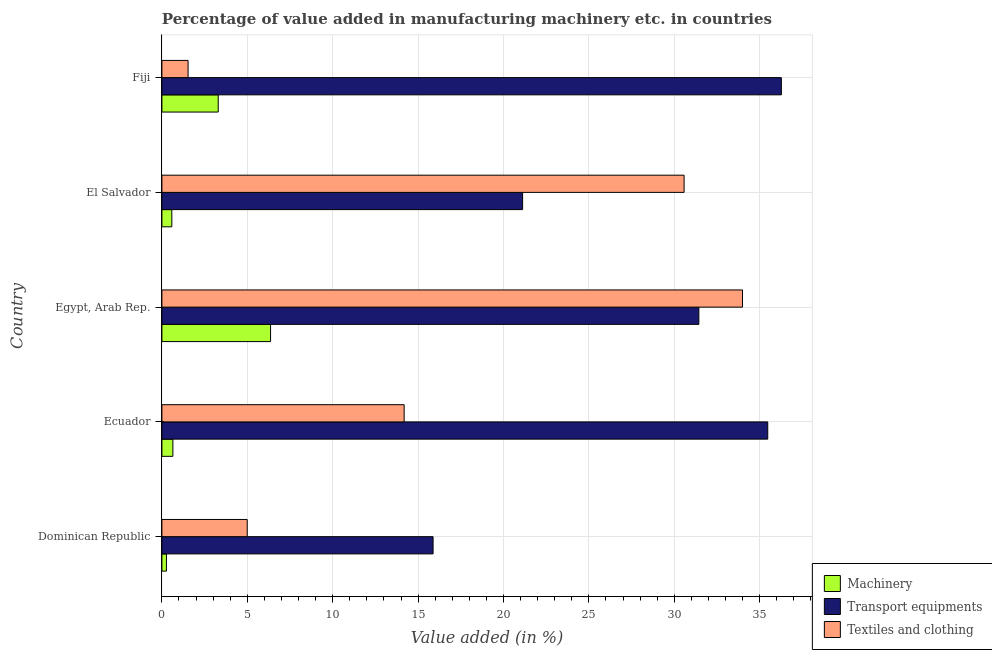How many different coloured bars are there?
Provide a short and direct response. 3. How many groups of bars are there?
Ensure brevity in your answer.  5. How many bars are there on the 4th tick from the top?
Your answer should be very brief. 3. How many bars are there on the 4th tick from the bottom?
Offer a very short reply. 3. What is the label of the 1st group of bars from the top?
Provide a succinct answer. Fiji. What is the value added in manufacturing machinery in El Salvador?
Provide a succinct answer. 0.58. Across all countries, what is the maximum value added in manufacturing transport equipments?
Keep it short and to the point. 36.27. Across all countries, what is the minimum value added in manufacturing machinery?
Ensure brevity in your answer.  0.27. In which country was the value added in manufacturing textile and clothing maximum?
Your answer should be very brief. Egypt, Arab Rep. In which country was the value added in manufacturing textile and clothing minimum?
Give a very brief answer. Fiji. What is the total value added in manufacturing machinery in the graph?
Keep it short and to the point. 11.15. What is the difference between the value added in manufacturing transport equipments in Dominican Republic and that in Fiji?
Your answer should be compact. -20.39. What is the difference between the value added in manufacturing machinery in Dominican Republic and the value added in manufacturing textile and clothing in Egypt, Arab Rep.?
Your answer should be compact. -33.73. What is the average value added in manufacturing machinery per country?
Your answer should be compact. 2.23. What is the difference between the value added in manufacturing textile and clothing and value added in manufacturing transport equipments in Dominican Republic?
Offer a terse response. -10.88. In how many countries, is the value added in manufacturing machinery greater than 4 %?
Your answer should be very brief. 1. What is the ratio of the value added in manufacturing textile and clothing in Egypt, Arab Rep. to that in El Salvador?
Ensure brevity in your answer.  1.11. Is the value added in manufacturing machinery in Ecuador less than that in Egypt, Arab Rep.?
Your answer should be very brief. Yes. Is the difference between the value added in manufacturing textile and clothing in Dominican Republic and El Salvador greater than the difference between the value added in manufacturing machinery in Dominican Republic and El Salvador?
Provide a succinct answer. No. What is the difference between the highest and the second highest value added in manufacturing textile and clothing?
Your answer should be compact. 3.42. What is the difference between the highest and the lowest value added in manufacturing textile and clothing?
Ensure brevity in your answer.  32.46. What does the 1st bar from the top in Dominican Republic represents?
Offer a terse response. Textiles and clothing. What does the 2nd bar from the bottom in Ecuador represents?
Make the answer very short. Transport equipments. Is it the case that in every country, the sum of the value added in manufacturing machinery and value added in manufacturing transport equipments is greater than the value added in manufacturing textile and clothing?
Provide a short and direct response. No. What is the difference between two consecutive major ticks on the X-axis?
Ensure brevity in your answer.  5. Does the graph contain grids?
Provide a succinct answer. Yes. What is the title of the graph?
Ensure brevity in your answer.  Percentage of value added in manufacturing machinery etc. in countries. Does "Tertiary" appear as one of the legend labels in the graph?
Ensure brevity in your answer.  No. What is the label or title of the X-axis?
Ensure brevity in your answer.  Value added (in %). What is the label or title of the Y-axis?
Provide a short and direct response. Country. What is the Value added (in %) of Machinery in Dominican Republic?
Offer a very short reply. 0.27. What is the Value added (in %) in Transport equipments in Dominican Republic?
Offer a very short reply. 15.88. What is the Value added (in %) in Textiles and clothing in Dominican Republic?
Offer a terse response. 5. What is the Value added (in %) of Machinery in Ecuador?
Keep it short and to the point. 0.64. What is the Value added (in %) in Transport equipments in Ecuador?
Provide a succinct answer. 35.47. What is the Value added (in %) in Textiles and clothing in Ecuador?
Provide a short and direct response. 14.18. What is the Value added (in %) of Machinery in Egypt, Arab Rep.?
Ensure brevity in your answer.  6.36. What is the Value added (in %) of Transport equipments in Egypt, Arab Rep.?
Keep it short and to the point. 31.44. What is the Value added (in %) in Textiles and clothing in Egypt, Arab Rep.?
Make the answer very short. 33.99. What is the Value added (in %) in Machinery in El Salvador?
Ensure brevity in your answer.  0.58. What is the Value added (in %) of Transport equipments in El Salvador?
Ensure brevity in your answer.  21.12. What is the Value added (in %) of Textiles and clothing in El Salvador?
Give a very brief answer. 30.57. What is the Value added (in %) of Machinery in Fiji?
Your response must be concise. 3.3. What is the Value added (in %) of Transport equipments in Fiji?
Provide a short and direct response. 36.27. What is the Value added (in %) in Textiles and clothing in Fiji?
Your answer should be very brief. 1.53. Across all countries, what is the maximum Value added (in %) of Machinery?
Your response must be concise. 6.36. Across all countries, what is the maximum Value added (in %) in Transport equipments?
Offer a terse response. 36.27. Across all countries, what is the maximum Value added (in %) in Textiles and clothing?
Keep it short and to the point. 33.99. Across all countries, what is the minimum Value added (in %) of Machinery?
Offer a terse response. 0.27. Across all countries, what is the minimum Value added (in %) of Transport equipments?
Offer a terse response. 15.88. Across all countries, what is the minimum Value added (in %) in Textiles and clothing?
Your response must be concise. 1.53. What is the total Value added (in %) in Machinery in the graph?
Provide a succinct answer. 11.15. What is the total Value added (in %) in Transport equipments in the graph?
Give a very brief answer. 140.18. What is the total Value added (in %) of Textiles and clothing in the graph?
Your answer should be compact. 85.28. What is the difference between the Value added (in %) in Machinery in Dominican Republic and that in Ecuador?
Your answer should be very brief. -0.38. What is the difference between the Value added (in %) in Transport equipments in Dominican Republic and that in Ecuador?
Ensure brevity in your answer.  -19.59. What is the difference between the Value added (in %) in Textiles and clothing in Dominican Republic and that in Ecuador?
Give a very brief answer. -9.19. What is the difference between the Value added (in %) in Machinery in Dominican Republic and that in Egypt, Arab Rep.?
Offer a very short reply. -6.1. What is the difference between the Value added (in %) of Transport equipments in Dominican Republic and that in Egypt, Arab Rep.?
Your answer should be compact. -15.56. What is the difference between the Value added (in %) in Textiles and clothing in Dominican Republic and that in Egypt, Arab Rep.?
Provide a succinct answer. -29. What is the difference between the Value added (in %) in Machinery in Dominican Republic and that in El Salvador?
Your answer should be compact. -0.32. What is the difference between the Value added (in %) in Transport equipments in Dominican Republic and that in El Salvador?
Make the answer very short. -5.24. What is the difference between the Value added (in %) in Textiles and clothing in Dominican Republic and that in El Salvador?
Ensure brevity in your answer.  -25.58. What is the difference between the Value added (in %) of Machinery in Dominican Republic and that in Fiji?
Your answer should be compact. -3.03. What is the difference between the Value added (in %) in Transport equipments in Dominican Republic and that in Fiji?
Keep it short and to the point. -20.39. What is the difference between the Value added (in %) of Textiles and clothing in Dominican Republic and that in Fiji?
Your answer should be compact. 3.46. What is the difference between the Value added (in %) in Machinery in Ecuador and that in Egypt, Arab Rep.?
Offer a very short reply. -5.72. What is the difference between the Value added (in %) in Transport equipments in Ecuador and that in Egypt, Arab Rep.?
Give a very brief answer. 4.03. What is the difference between the Value added (in %) of Textiles and clothing in Ecuador and that in Egypt, Arab Rep.?
Provide a short and direct response. -19.81. What is the difference between the Value added (in %) in Machinery in Ecuador and that in El Salvador?
Offer a very short reply. 0.06. What is the difference between the Value added (in %) of Transport equipments in Ecuador and that in El Salvador?
Offer a terse response. 14.35. What is the difference between the Value added (in %) in Textiles and clothing in Ecuador and that in El Salvador?
Provide a short and direct response. -16.39. What is the difference between the Value added (in %) of Machinery in Ecuador and that in Fiji?
Keep it short and to the point. -2.65. What is the difference between the Value added (in %) of Transport equipments in Ecuador and that in Fiji?
Give a very brief answer. -0.8. What is the difference between the Value added (in %) in Textiles and clothing in Ecuador and that in Fiji?
Ensure brevity in your answer.  12.65. What is the difference between the Value added (in %) in Machinery in Egypt, Arab Rep. and that in El Salvador?
Make the answer very short. 5.78. What is the difference between the Value added (in %) in Transport equipments in Egypt, Arab Rep. and that in El Salvador?
Give a very brief answer. 10.32. What is the difference between the Value added (in %) of Textiles and clothing in Egypt, Arab Rep. and that in El Salvador?
Ensure brevity in your answer.  3.42. What is the difference between the Value added (in %) in Machinery in Egypt, Arab Rep. and that in Fiji?
Give a very brief answer. 3.06. What is the difference between the Value added (in %) of Transport equipments in Egypt, Arab Rep. and that in Fiji?
Your answer should be compact. -4.83. What is the difference between the Value added (in %) in Textiles and clothing in Egypt, Arab Rep. and that in Fiji?
Offer a very short reply. 32.46. What is the difference between the Value added (in %) in Machinery in El Salvador and that in Fiji?
Provide a short and direct response. -2.72. What is the difference between the Value added (in %) in Transport equipments in El Salvador and that in Fiji?
Provide a short and direct response. -15.15. What is the difference between the Value added (in %) of Textiles and clothing in El Salvador and that in Fiji?
Your response must be concise. 29.04. What is the difference between the Value added (in %) in Machinery in Dominican Republic and the Value added (in %) in Transport equipments in Ecuador?
Your answer should be compact. -35.21. What is the difference between the Value added (in %) of Machinery in Dominican Republic and the Value added (in %) of Textiles and clothing in Ecuador?
Your response must be concise. -13.92. What is the difference between the Value added (in %) in Transport equipments in Dominican Republic and the Value added (in %) in Textiles and clothing in Ecuador?
Ensure brevity in your answer.  1.69. What is the difference between the Value added (in %) of Machinery in Dominican Republic and the Value added (in %) of Transport equipments in Egypt, Arab Rep.?
Provide a succinct answer. -31.17. What is the difference between the Value added (in %) in Machinery in Dominican Republic and the Value added (in %) in Textiles and clothing in Egypt, Arab Rep.?
Offer a terse response. -33.73. What is the difference between the Value added (in %) in Transport equipments in Dominican Republic and the Value added (in %) in Textiles and clothing in Egypt, Arab Rep.?
Give a very brief answer. -18.12. What is the difference between the Value added (in %) of Machinery in Dominican Republic and the Value added (in %) of Transport equipments in El Salvador?
Your answer should be very brief. -20.85. What is the difference between the Value added (in %) in Machinery in Dominican Republic and the Value added (in %) in Textiles and clothing in El Salvador?
Make the answer very short. -30.31. What is the difference between the Value added (in %) in Transport equipments in Dominican Republic and the Value added (in %) in Textiles and clothing in El Salvador?
Keep it short and to the point. -14.7. What is the difference between the Value added (in %) of Machinery in Dominican Republic and the Value added (in %) of Transport equipments in Fiji?
Offer a very short reply. -36. What is the difference between the Value added (in %) of Machinery in Dominican Republic and the Value added (in %) of Textiles and clothing in Fiji?
Provide a short and direct response. -1.27. What is the difference between the Value added (in %) of Transport equipments in Dominican Republic and the Value added (in %) of Textiles and clothing in Fiji?
Make the answer very short. 14.34. What is the difference between the Value added (in %) of Machinery in Ecuador and the Value added (in %) of Transport equipments in Egypt, Arab Rep.?
Your response must be concise. -30.79. What is the difference between the Value added (in %) of Machinery in Ecuador and the Value added (in %) of Textiles and clothing in Egypt, Arab Rep.?
Offer a very short reply. -33.35. What is the difference between the Value added (in %) in Transport equipments in Ecuador and the Value added (in %) in Textiles and clothing in Egypt, Arab Rep.?
Your response must be concise. 1.48. What is the difference between the Value added (in %) of Machinery in Ecuador and the Value added (in %) of Transport equipments in El Salvador?
Offer a very short reply. -20.48. What is the difference between the Value added (in %) in Machinery in Ecuador and the Value added (in %) in Textiles and clothing in El Salvador?
Offer a very short reply. -29.93. What is the difference between the Value added (in %) in Transport equipments in Ecuador and the Value added (in %) in Textiles and clothing in El Salvador?
Keep it short and to the point. 4.9. What is the difference between the Value added (in %) of Machinery in Ecuador and the Value added (in %) of Transport equipments in Fiji?
Provide a succinct answer. -35.63. What is the difference between the Value added (in %) in Machinery in Ecuador and the Value added (in %) in Textiles and clothing in Fiji?
Provide a succinct answer. -0.89. What is the difference between the Value added (in %) of Transport equipments in Ecuador and the Value added (in %) of Textiles and clothing in Fiji?
Provide a succinct answer. 33.94. What is the difference between the Value added (in %) of Machinery in Egypt, Arab Rep. and the Value added (in %) of Transport equipments in El Salvador?
Offer a very short reply. -14.76. What is the difference between the Value added (in %) in Machinery in Egypt, Arab Rep. and the Value added (in %) in Textiles and clothing in El Salvador?
Offer a very short reply. -24.21. What is the difference between the Value added (in %) in Transport equipments in Egypt, Arab Rep. and the Value added (in %) in Textiles and clothing in El Salvador?
Make the answer very short. 0.86. What is the difference between the Value added (in %) of Machinery in Egypt, Arab Rep. and the Value added (in %) of Transport equipments in Fiji?
Offer a terse response. -29.91. What is the difference between the Value added (in %) in Machinery in Egypt, Arab Rep. and the Value added (in %) in Textiles and clothing in Fiji?
Provide a succinct answer. 4.83. What is the difference between the Value added (in %) in Transport equipments in Egypt, Arab Rep. and the Value added (in %) in Textiles and clothing in Fiji?
Your answer should be compact. 29.9. What is the difference between the Value added (in %) in Machinery in El Salvador and the Value added (in %) in Transport equipments in Fiji?
Provide a short and direct response. -35.69. What is the difference between the Value added (in %) in Machinery in El Salvador and the Value added (in %) in Textiles and clothing in Fiji?
Give a very brief answer. -0.95. What is the difference between the Value added (in %) in Transport equipments in El Salvador and the Value added (in %) in Textiles and clothing in Fiji?
Keep it short and to the point. 19.59. What is the average Value added (in %) in Machinery per country?
Your answer should be compact. 2.23. What is the average Value added (in %) in Transport equipments per country?
Offer a very short reply. 28.04. What is the average Value added (in %) in Textiles and clothing per country?
Provide a short and direct response. 17.06. What is the difference between the Value added (in %) in Machinery and Value added (in %) in Transport equipments in Dominican Republic?
Offer a terse response. -15.61. What is the difference between the Value added (in %) in Machinery and Value added (in %) in Textiles and clothing in Dominican Republic?
Keep it short and to the point. -4.73. What is the difference between the Value added (in %) of Transport equipments and Value added (in %) of Textiles and clothing in Dominican Republic?
Your answer should be compact. 10.88. What is the difference between the Value added (in %) in Machinery and Value added (in %) in Transport equipments in Ecuador?
Offer a terse response. -34.83. What is the difference between the Value added (in %) of Machinery and Value added (in %) of Textiles and clothing in Ecuador?
Make the answer very short. -13.54. What is the difference between the Value added (in %) in Transport equipments and Value added (in %) in Textiles and clothing in Ecuador?
Your answer should be compact. 21.29. What is the difference between the Value added (in %) of Machinery and Value added (in %) of Transport equipments in Egypt, Arab Rep.?
Your response must be concise. -25.08. What is the difference between the Value added (in %) of Machinery and Value added (in %) of Textiles and clothing in Egypt, Arab Rep.?
Offer a terse response. -27.63. What is the difference between the Value added (in %) of Transport equipments and Value added (in %) of Textiles and clothing in Egypt, Arab Rep.?
Offer a terse response. -2.56. What is the difference between the Value added (in %) of Machinery and Value added (in %) of Transport equipments in El Salvador?
Keep it short and to the point. -20.54. What is the difference between the Value added (in %) in Machinery and Value added (in %) in Textiles and clothing in El Salvador?
Your response must be concise. -29.99. What is the difference between the Value added (in %) of Transport equipments and Value added (in %) of Textiles and clothing in El Salvador?
Give a very brief answer. -9.46. What is the difference between the Value added (in %) of Machinery and Value added (in %) of Transport equipments in Fiji?
Give a very brief answer. -32.97. What is the difference between the Value added (in %) in Machinery and Value added (in %) in Textiles and clothing in Fiji?
Offer a very short reply. 1.77. What is the difference between the Value added (in %) of Transport equipments and Value added (in %) of Textiles and clothing in Fiji?
Give a very brief answer. 34.74. What is the ratio of the Value added (in %) in Machinery in Dominican Republic to that in Ecuador?
Give a very brief answer. 0.41. What is the ratio of the Value added (in %) in Transport equipments in Dominican Republic to that in Ecuador?
Keep it short and to the point. 0.45. What is the ratio of the Value added (in %) of Textiles and clothing in Dominican Republic to that in Ecuador?
Offer a very short reply. 0.35. What is the ratio of the Value added (in %) of Machinery in Dominican Republic to that in Egypt, Arab Rep.?
Keep it short and to the point. 0.04. What is the ratio of the Value added (in %) of Transport equipments in Dominican Republic to that in Egypt, Arab Rep.?
Make the answer very short. 0.51. What is the ratio of the Value added (in %) of Textiles and clothing in Dominican Republic to that in Egypt, Arab Rep.?
Make the answer very short. 0.15. What is the ratio of the Value added (in %) of Machinery in Dominican Republic to that in El Salvador?
Keep it short and to the point. 0.46. What is the ratio of the Value added (in %) of Transport equipments in Dominican Republic to that in El Salvador?
Make the answer very short. 0.75. What is the ratio of the Value added (in %) in Textiles and clothing in Dominican Republic to that in El Salvador?
Offer a very short reply. 0.16. What is the ratio of the Value added (in %) in Machinery in Dominican Republic to that in Fiji?
Provide a succinct answer. 0.08. What is the ratio of the Value added (in %) of Transport equipments in Dominican Republic to that in Fiji?
Give a very brief answer. 0.44. What is the ratio of the Value added (in %) of Textiles and clothing in Dominican Republic to that in Fiji?
Ensure brevity in your answer.  3.26. What is the ratio of the Value added (in %) of Machinery in Ecuador to that in Egypt, Arab Rep.?
Offer a very short reply. 0.1. What is the ratio of the Value added (in %) in Transport equipments in Ecuador to that in Egypt, Arab Rep.?
Give a very brief answer. 1.13. What is the ratio of the Value added (in %) in Textiles and clothing in Ecuador to that in Egypt, Arab Rep.?
Your answer should be very brief. 0.42. What is the ratio of the Value added (in %) in Machinery in Ecuador to that in El Salvador?
Make the answer very short. 1.11. What is the ratio of the Value added (in %) in Transport equipments in Ecuador to that in El Salvador?
Offer a very short reply. 1.68. What is the ratio of the Value added (in %) of Textiles and clothing in Ecuador to that in El Salvador?
Your response must be concise. 0.46. What is the ratio of the Value added (in %) in Machinery in Ecuador to that in Fiji?
Your answer should be very brief. 0.2. What is the ratio of the Value added (in %) in Textiles and clothing in Ecuador to that in Fiji?
Provide a short and direct response. 9.25. What is the ratio of the Value added (in %) in Machinery in Egypt, Arab Rep. to that in El Salvador?
Provide a short and direct response. 10.94. What is the ratio of the Value added (in %) in Transport equipments in Egypt, Arab Rep. to that in El Salvador?
Give a very brief answer. 1.49. What is the ratio of the Value added (in %) of Textiles and clothing in Egypt, Arab Rep. to that in El Salvador?
Provide a short and direct response. 1.11. What is the ratio of the Value added (in %) of Machinery in Egypt, Arab Rep. to that in Fiji?
Provide a succinct answer. 1.93. What is the ratio of the Value added (in %) of Transport equipments in Egypt, Arab Rep. to that in Fiji?
Offer a very short reply. 0.87. What is the ratio of the Value added (in %) of Textiles and clothing in Egypt, Arab Rep. to that in Fiji?
Your answer should be very brief. 22.17. What is the ratio of the Value added (in %) of Machinery in El Salvador to that in Fiji?
Make the answer very short. 0.18. What is the ratio of the Value added (in %) of Transport equipments in El Salvador to that in Fiji?
Your answer should be very brief. 0.58. What is the ratio of the Value added (in %) in Textiles and clothing in El Salvador to that in Fiji?
Offer a very short reply. 19.94. What is the difference between the highest and the second highest Value added (in %) in Machinery?
Provide a short and direct response. 3.06. What is the difference between the highest and the second highest Value added (in %) of Transport equipments?
Your answer should be very brief. 0.8. What is the difference between the highest and the second highest Value added (in %) in Textiles and clothing?
Provide a short and direct response. 3.42. What is the difference between the highest and the lowest Value added (in %) of Machinery?
Offer a terse response. 6.1. What is the difference between the highest and the lowest Value added (in %) of Transport equipments?
Offer a terse response. 20.39. What is the difference between the highest and the lowest Value added (in %) in Textiles and clothing?
Keep it short and to the point. 32.46. 